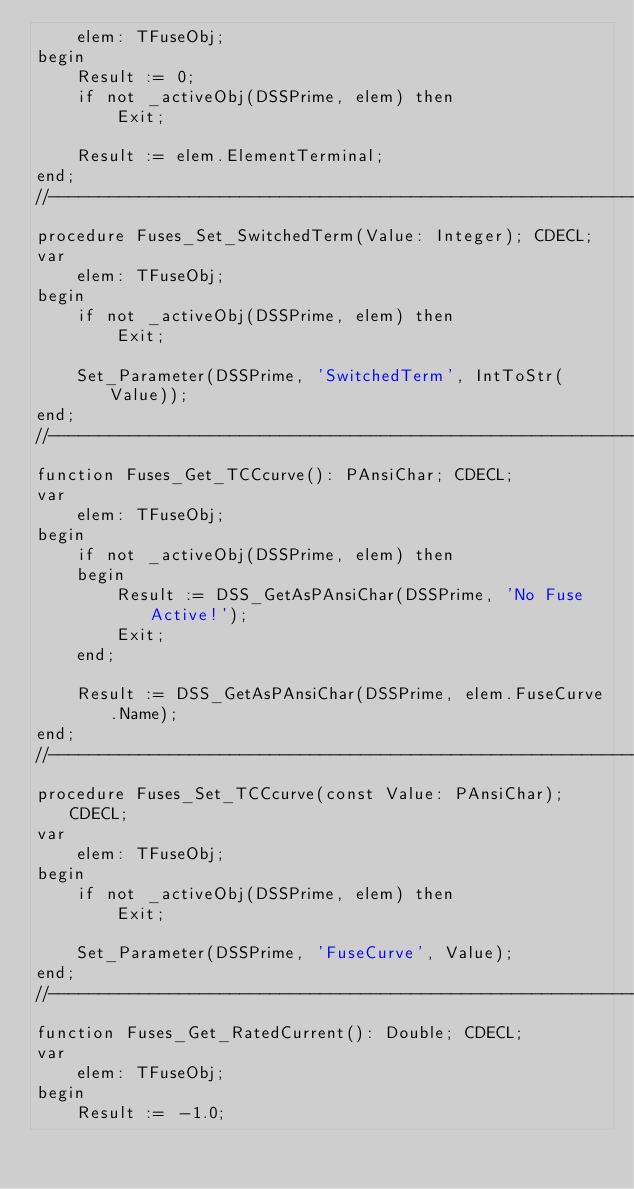<code> <loc_0><loc_0><loc_500><loc_500><_Pascal_>    elem: TFuseObj;
begin
    Result := 0;
    if not _activeObj(DSSPrime, elem) then
        Exit;

    Result := elem.ElementTerminal;
end;
//------------------------------------------------------------------------------
procedure Fuses_Set_SwitchedTerm(Value: Integer); CDECL;
var
    elem: TFuseObj;
begin
    if not _activeObj(DSSPrime, elem) then
        Exit;

    Set_Parameter(DSSPrime, 'SwitchedTerm', IntToStr(Value));
end;
//------------------------------------------------------------------------------
function Fuses_Get_TCCcurve(): PAnsiChar; CDECL;
var
    elem: TFuseObj;
begin
    if not _activeObj(DSSPrime, elem) then
    begin
        Result := DSS_GetAsPAnsiChar(DSSPrime, 'No Fuse Active!');
        Exit;
    end;

    Result := DSS_GetAsPAnsiChar(DSSPrime, elem.FuseCurve.Name);
end;
//------------------------------------------------------------------------------
procedure Fuses_Set_TCCcurve(const Value: PAnsiChar); CDECL;
var
    elem: TFuseObj;
begin
    if not _activeObj(DSSPrime, elem) then
        Exit;

    Set_Parameter(DSSPrime, 'FuseCurve', Value);
end;
//------------------------------------------------------------------------------
function Fuses_Get_RatedCurrent(): Double; CDECL;
var
    elem: TFuseObj;
begin
    Result := -1.0;</code> 